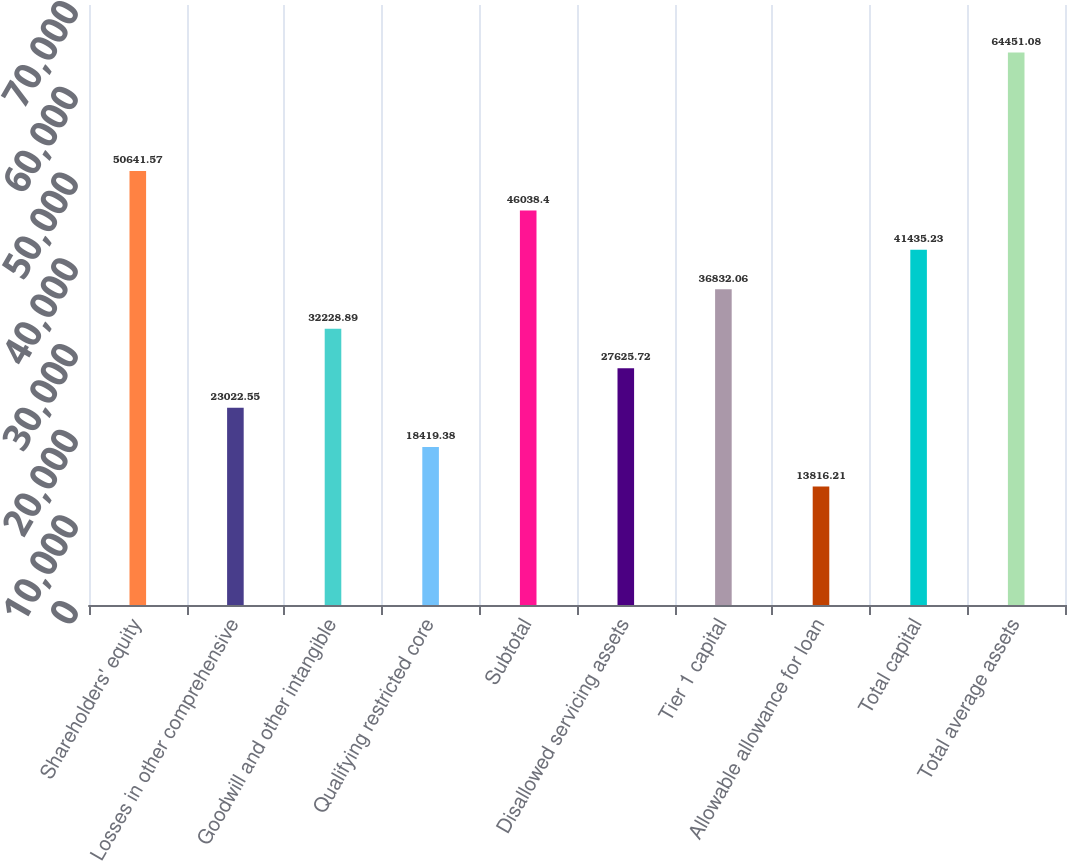<chart> <loc_0><loc_0><loc_500><loc_500><bar_chart><fcel>Shareholders' equity<fcel>Losses in other comprehensive<fcel>Goodwill and other intangible<fcel>Qualifying restricted core<fcel>Subtotal<fcel>Disallowed servicing assets<fcel>Tier 1 capital<fcel>Allowable allowance for loan<fcel>Total capital<fcel>Total average assets<nl><fcel>50641.6<fcel>23022.5<fcel>32228.9<fcel>18419.4<fcel>46038.4<fcel>27625.7<fcel>36832.1<fcel>13816.2<fcel>41435.2<fcel>64451.1<nl></chart> 